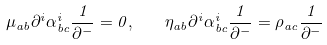<formula> <loc_0><loc_0><loc_500><loc_500>\mu _ { a b } \partial ^ { i } \alpha ^ { i } _ { b c } \frac { 1 } { \partial ^ { - } } = 0 , \quad \eta _ { a b } \partial ^ { i } \alpha ^ { i } _ { b c } \frac { 1 } { \partial ^ { - } } = \rho _ { a c } \frac { 1 } { \partial ^ { - } }</formula> 